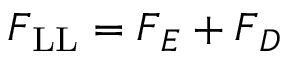<formula> <loc_0><loc_0><loc_500><loc_500>F _ { L L } = F _ { E } + F _ { D }</formula> 